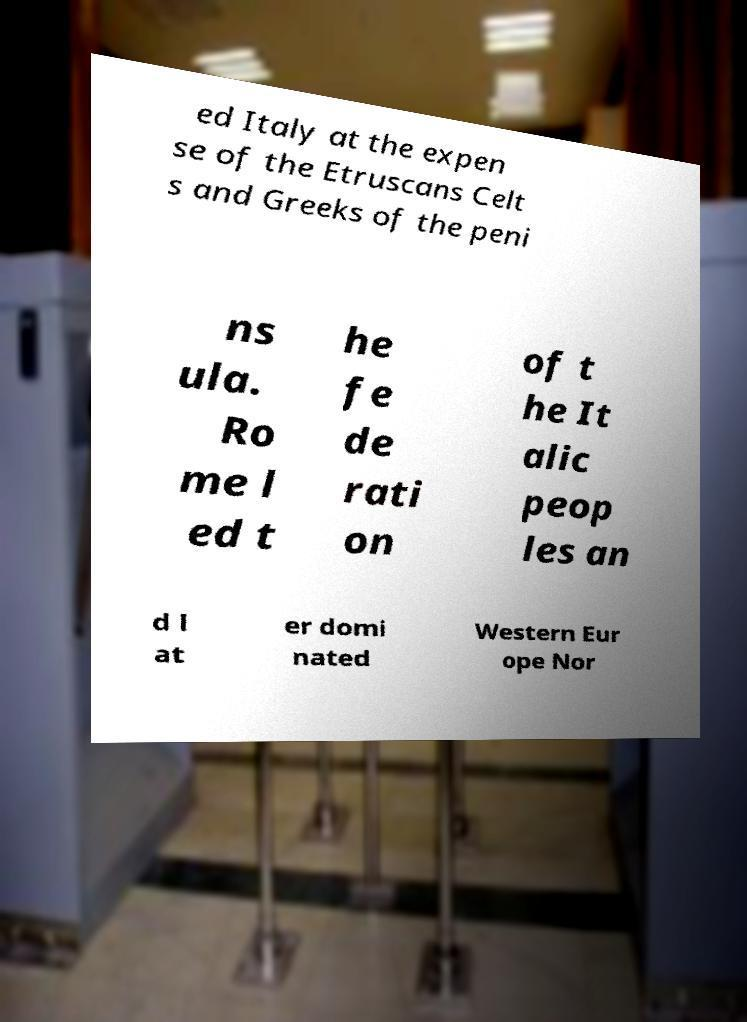Could you extract and type out the text from this image? ed Italy at the expen se of the Etruscans Celt s and Greeks of the peni ns ula. Ro me l ed t he fe de rati on of t he It alic peop les an d l at er domi nated Western Eur ope Nor 